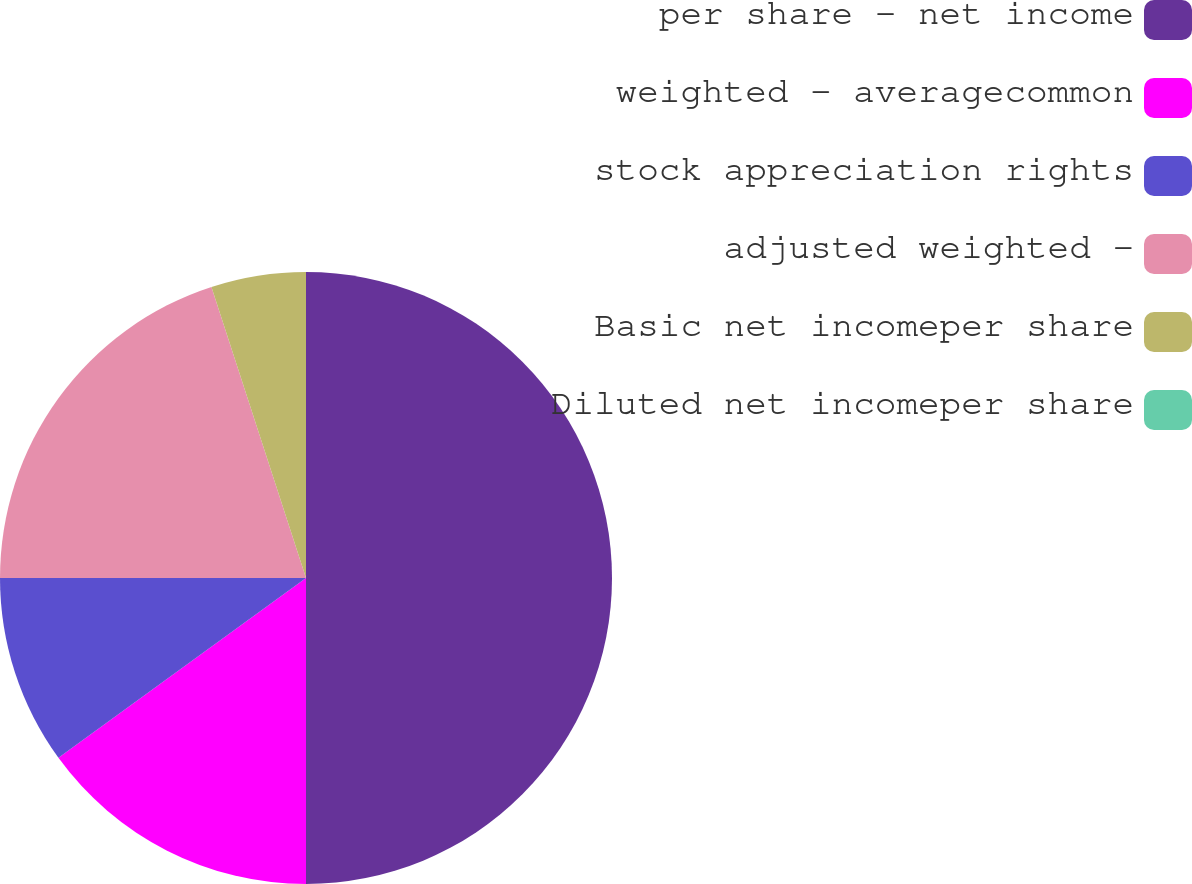Convert chart to OTSL. <chart><loc_0><loc_0><loc_500><loc_500><pie_chart><fcel>per share - net income<fcel>weighted - averagecommon<fcel>stock appreciation rights<fcel>adjusted weighted -<fcel>Basic net incomeper share<fcel>Diluted net incomeper share<nl><fcel>50.0%<fcel>15.0%<fcel>10.0%<fcel>20.0%<fcel>5.0%<fcel>0.0%<nl></chart> 